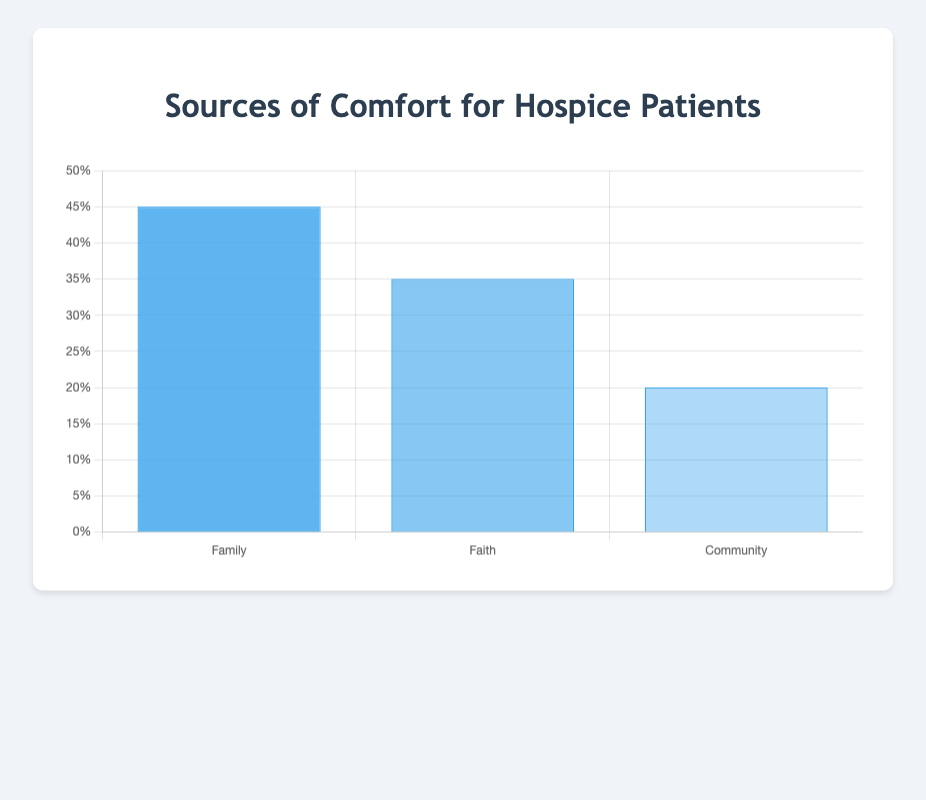Which source of comfort has the highest percentage? Looking at the bar chart, the bar representing "Family" is the tallest among all, indicating that "Family" has the highest percentage.
Answer: Family How much more comforting is "Family" compared to "Community"? According to the bar chart, "Family" is at 45% and "Community" is at 20%. The difference is 45% - 20% = 25%.
Answer: 25% What is the average percentage of comfort provided by "Family", "Faith", and "Community"? Adding up the percentages: 45% (Family) + 35% (Faith) + 20% (Community) = 100%. Dividing by the number of categories (3): 100% / 3 = 33.33%.
Answer: 33.33% Which source of comfort is indicated as being preferred by a minority of hospice patients? "Community" has the lowest percentage on the bar chart, indicating it is preferred by a minority of patients, at 20%.
Answer: Community Is "Faith" a more common source of comfort than "Community"? Comparing the heights of the bars for "Faith" and "Community", the bar for "Faith" is taller, with 35% for "Faith" and 20% for "Community".
Answer: Yes What is the total percentage of comfort provided cumulatively by "Faith" and "Family"? Adding the percentages for "Faith" and "Family", we get 35% + 45% = 80%.
Answer: 80% Are half of the patients comforted by either "Faith" or "Community"? Adding the percentages of "Faith" (35%) and "Community" (20%), we get 35% + 20% = 55%, which is more than half.
Answer: No Which visual characteristic helps distinguish the categories on the chart? The different shades of blue (darker for higher percentages and lighter for lower) effectively distinguish the categories visually.
Answer: Shades of blue Which subcategory of "Faith" contributes the most to its overall percentage? Looking into the data, "personal prayer" has the highest subcategory percentage within "Faith" at 18%.
Answer: Personal prayer 